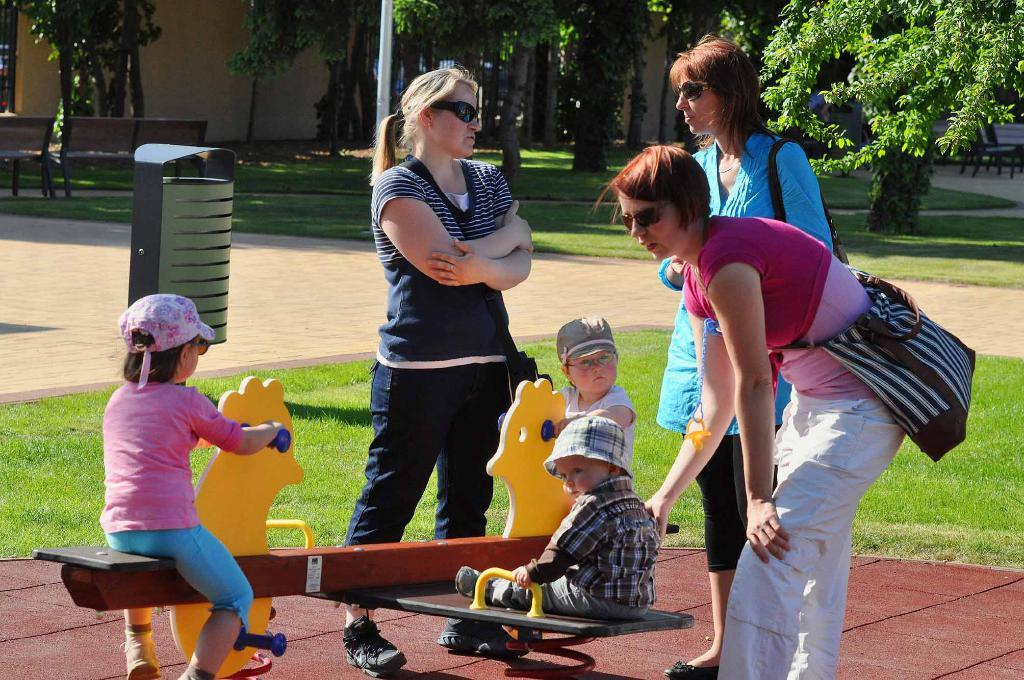How many kids are in the image? There are three kids in the image. What else can be seen in the image besides the kids? There are people, trees, plants, poles, benches, and houses in the image. Can you describe the setting of the image? The image appears to be set in an outdoor area with trees, plants, and houses nearby. What type of fang can be seen in the image? There is no fang present in the image. What experience can be gained by observing the image? The image itself does not provide an experience, but it may evoke feelings or memories related to outdoor settings or childhood activities. 